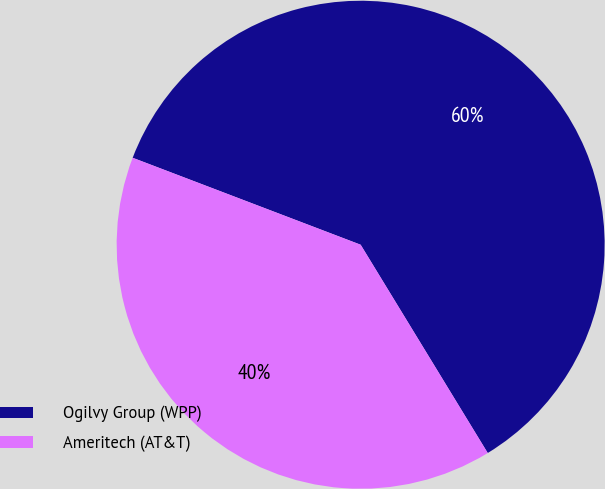<chart> <loc_0><loc_0><loc_500><loc_500><pie_chart><fcel>Ogilvy Group (WPP)<fcel>Ameritech (AT&T)<nl><fcel>60.48%<fcel>39.52%<nl></chart> 